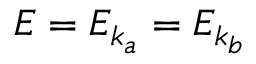<formula> <loc_0><loc_0><loc_500><loc_500>E = E _ { k _ { a } } = E _ { k _ { b } }</formula> 